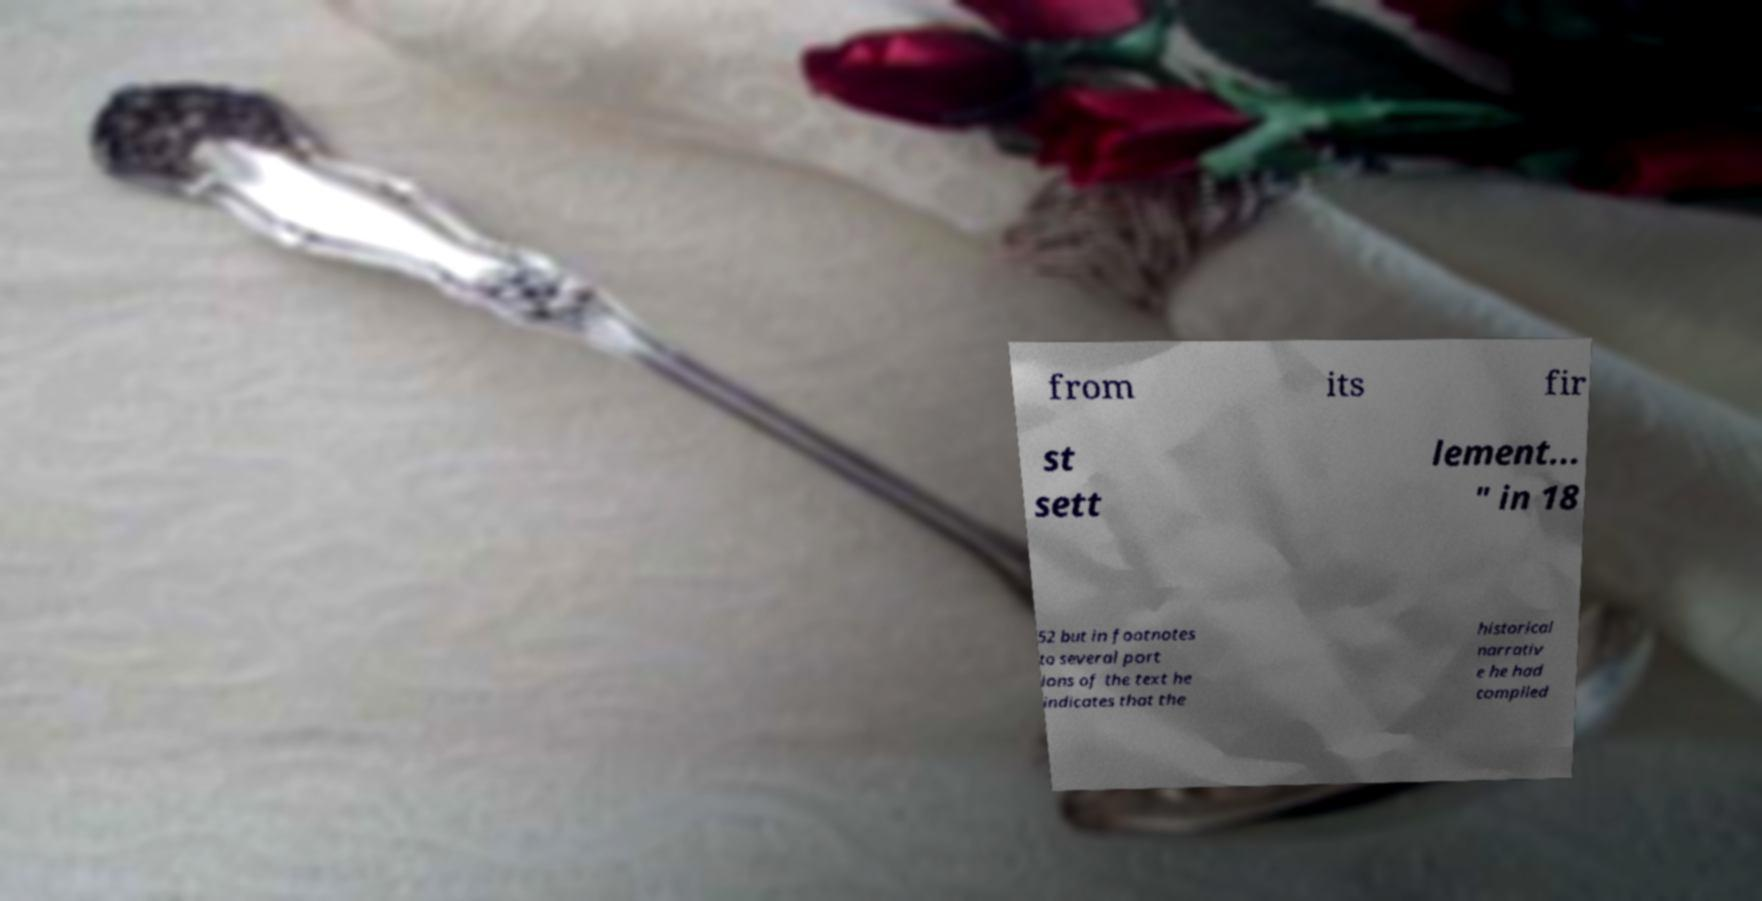What messages or text are displayed in this image? I need them in a readable, typed format. from its fir st sett lement... " in 18 52 but in footnotes to several port ions of the text he indicates that the historical narrativ e he had compiled 